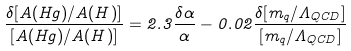Convert formula to latex. <formula><loc_0><loc_0><loc_500><loc_500>\frac { \delta [ A ( H g ) / A ( H ) ] } { [ A ( H g ) / A ( H ) ] } = 2 . 3 \frac { \delta \alpha } { \alpha } - 0 . 0 2 \frac { \delta [ m _ { q } / \Lambda _ { Q C D } ] } { [ m _ { q } / \Lambda _ { Q C D } ] }</formula> 